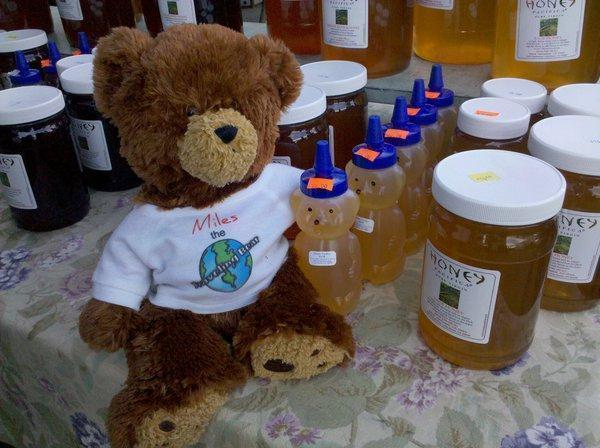What color are the tags on top of the honey dispensers?
Select the accurate response from the four choices given to answer the question.
Options: Orange, white, pink, purple. Orange. 